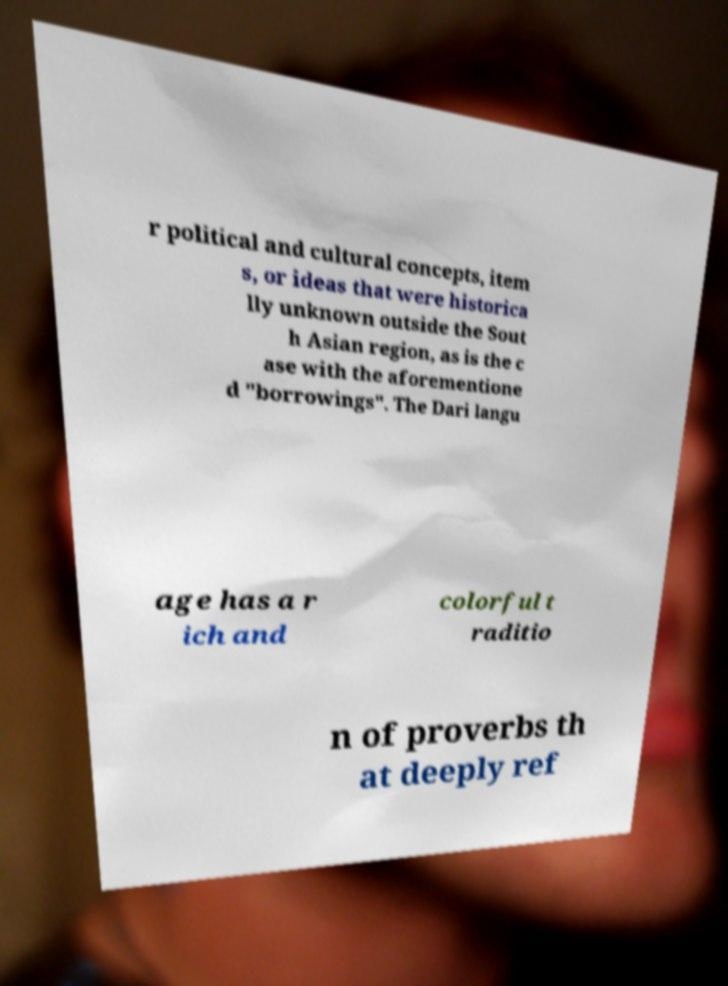Could you extract and type out the text from this image? r political and cultural concepts, item s, or ideas that were historica lly unknown outside the Sout h Asian region, as is the c ase with the aforementione d "borrowings". The Dari langu age has a r ich and colorful t raditio n of proverbs th at deeply ref 